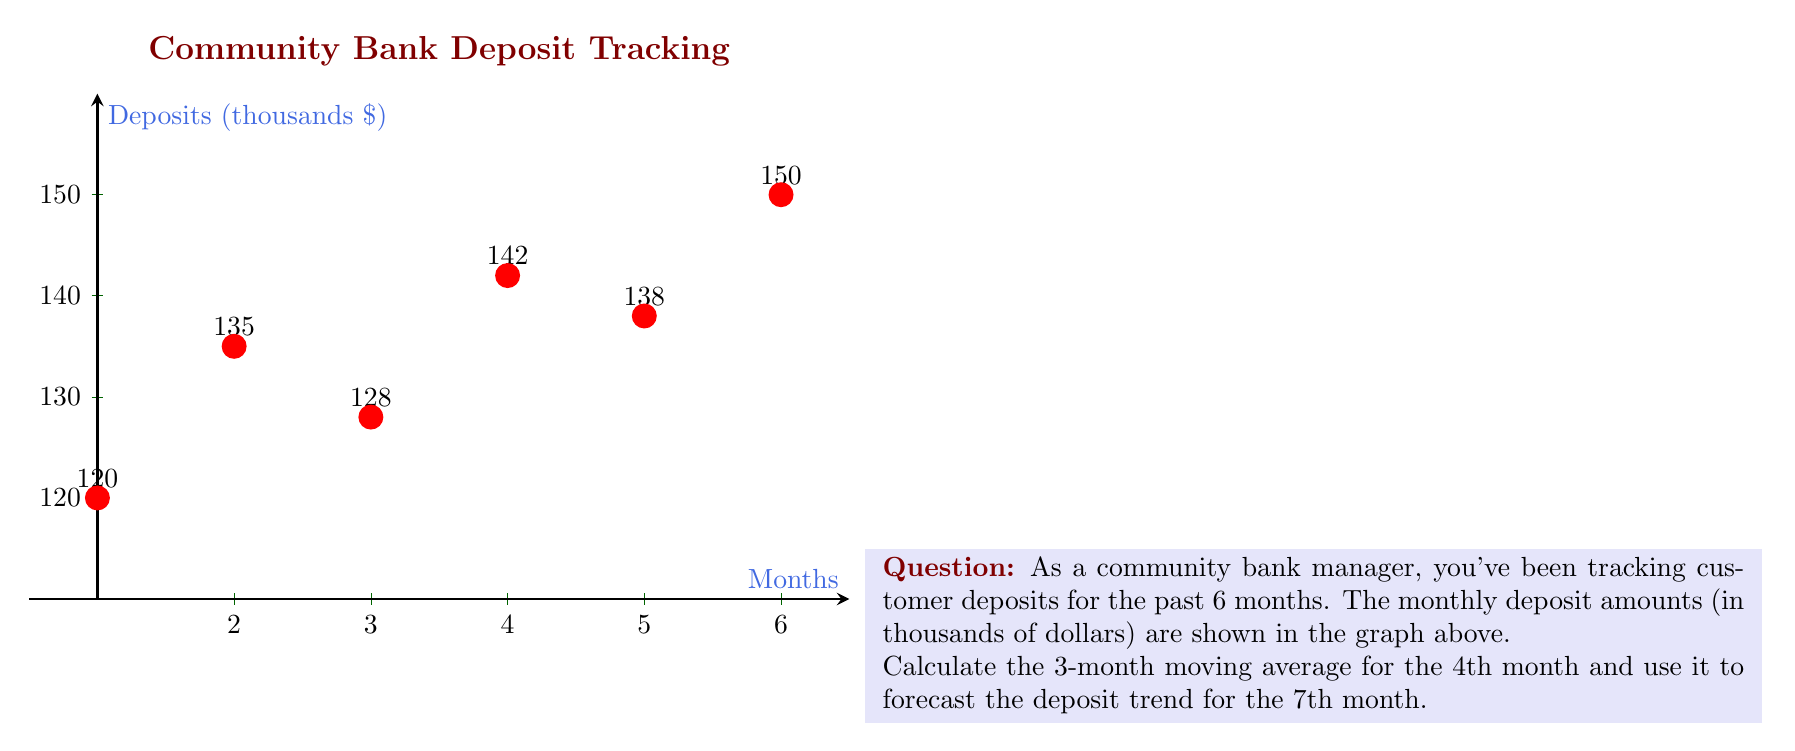Teach me how to tackle this problem. To solve this problem, we'll follow these steps:

1) The 3-month moving average is calculated by taking the average of the current month and the two preceding months.

2) For the 4th month, we need to consider the deposits from months 2, 3, and 4.

3) Let's calculate the 3-month moving average for the 4th month:

   $$\text{4th month MA} = \frac{135 + 128 + 142}{3} = \frac{405}{3} = 135$$

4) To forecast the trend for the 7th month, we can assume that the rate of change between the 4th month's moving average and the actual 6th month value will continue.

5) Calculate the rate of change:
   $$\text{Rate of change} = \frac{150 - 135}{135} \approx 0.1111 \text{ or } 11.11\%$$

6) Apply this rate of change to the 6th month value to forecast the 7th month:
   $$\text{7th month forecast} = 150 * (1 + 0.1111) = 150 * 1.1111 \approx 166.67$$

Therefore, the forecast for the 7th month, based on the 3-month moving average trend, is approximately $166,670.
Answer: $166,670 